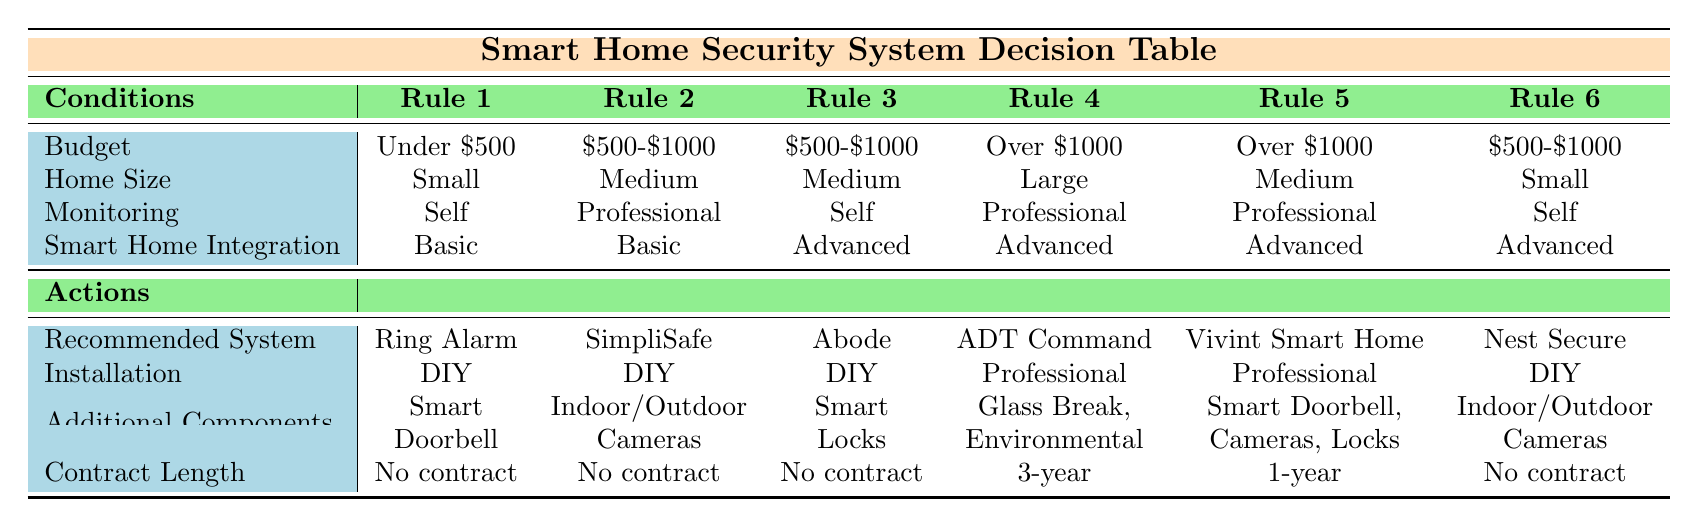What is the recommended system for a small home under a $500 budget? The table indicates that for a budget under $500, the recommended system is "Ring Alarm" under Rule 1.
Answer: Ring Alarm Which installation option is suggested for professional monitoring in large homes over $1000? According to Rule 4, for large homes over $1000 with professional monitoring, the installation option recommended is "Professional".
Answer: Professional Is there additional equipment included with the SimpliSafe system? Referring to Rule 2, the additional components listed with SimpliSafe are "Indoor/Outdoor Cameras".
Answer: Yes What is the total number of different recommended systems listed for budgets between $500 and $1000? There are three systems recommended in the budget range of $500-$1000: "SimpliSafe", "Abode", and "Nest Secure", which totals to three systems.
Answer: 3 For a medium-sized home with professional monitoring, which recommended system has a one-year contract? Looking at Rule 5, for a medium-sized home with professional monitoring, the recommended system is "Vivint Smart Home" and it includes a one-year contract.
Answer: Vivint Smart Home In terms of contract lengths, does the Ring Alarm option require any contract? Rule 1 states that the contract length for "Ring Alarm" is "No contract".
Answer: Yes If I have a small home and want advanced smart home integration, which system should I choose? Referring to Rule 6, for a small home with advanced smart home integration, the recommended system is "Nest Secure".
Answer: Nest Secure How many systems require environmental sensors as additional components? The table shows that only one system (ADT Command) in Rule 4 lists "Glass Break Sensors, Environmental Sensors" as additional components, thus the count is one.
Answer: 1 Which budget category corresponds to the use of smart locks as an additional component? According to Rule 3, the budget category is "$500-$1000" which corresponds to "Abode" as the recommended system that includes "Smart Locks" as an additional component.
Answer: $500-$1000 